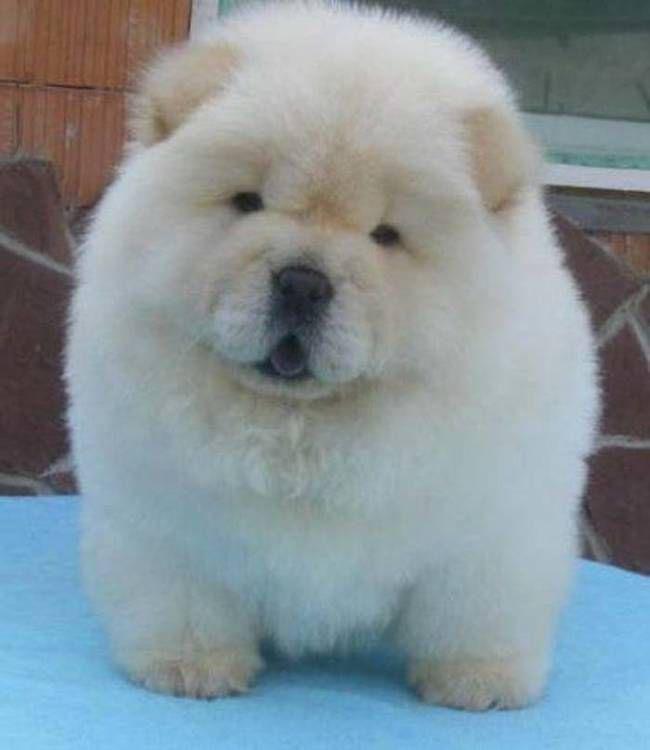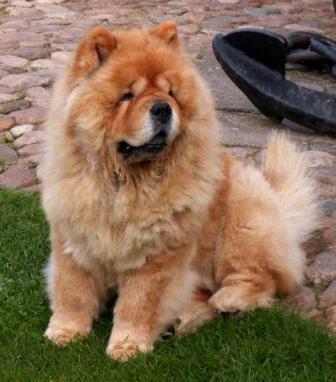The first image is the image on the left, the second image is the image on the right. Considering the images on both sides, is "There is at most 3 dogs." valid? Answer yes or no. Yes. The first image is the image on the left, the second image is the image on the right. Examine the images to the left and right. Is the description "There are no more than 3 dogs." accurate? Answer yes or no. Yes. 